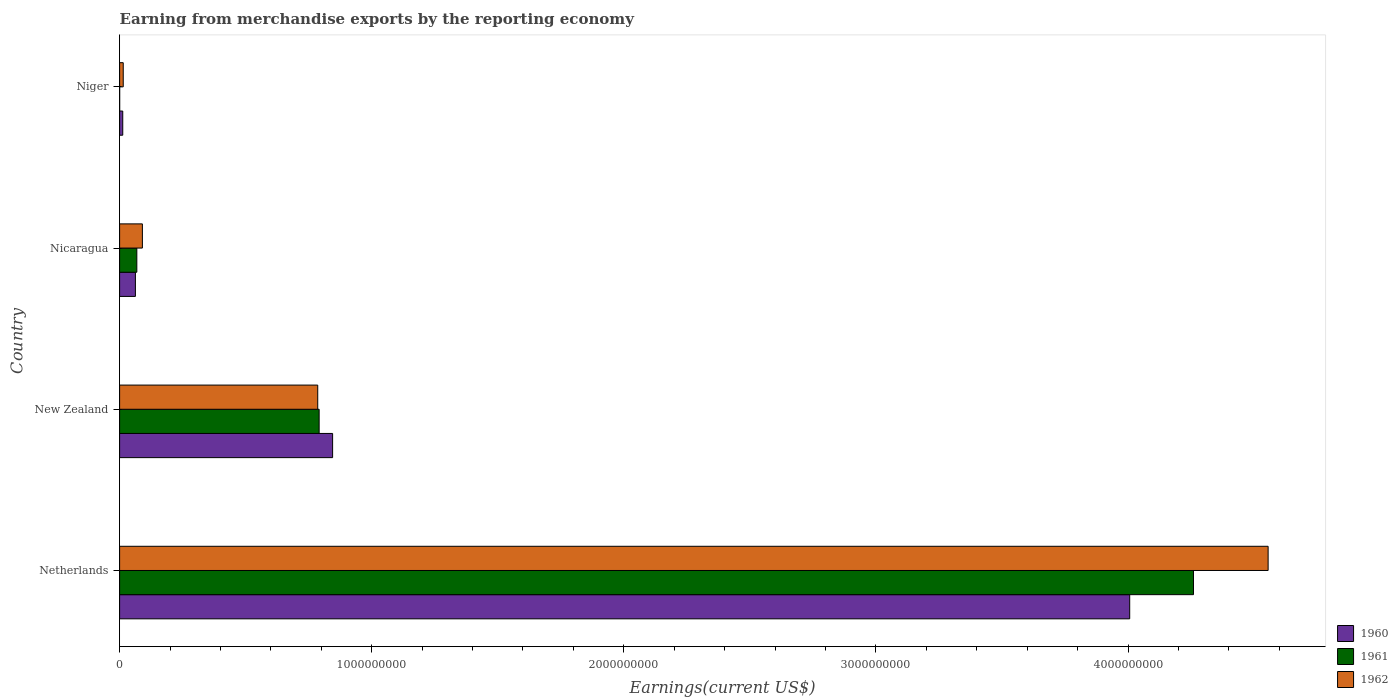How many groups of bars are there?
Provide a succinct answer. 4. What is the label of the 3rd group of bars from the top?
Provide a short and direct response. New Zealand. What is the amount earned from merchandise exports in 1961 in Nicaragua?
Your response must be concise. 6.83e+07. Across all countries, what is the maximum amount earned from merchandise exports in 1961?
Your answer should be compact. 4.26e+09. Across all countries, what is the minimum amount earned from merchandise exports in 1962?
Your answer should be very brief. 1.44e+07. In which country was the amount earned from merchandise exports in 1962 maximum?
Ensure brevity in your answer.  Netherlands. In which country was the amount earned from merchandise exports in 1961 minimum?
Offer a very short reply. Niger. What is the total amount earned from merchandise exports in 1961 in the graph?
Your response must be concise. 5.12e+09. What is the difference between the amount earned from merchandise exports in 1960 in Netherlands and that in Nicaragua?
Offer a very short reply. 3.94e+09. What is the difference between the amount earned from merchandise exports in 1962 in New Zealand and the amount earned from merchandise exports in 1960 in Niger?
Give a very brief answer. 7.73e+08. What is the average amount earned from merchandise exports in 1961 per country?
Give a very brief answer. 1.28e+09. What is the difference between the amount earned from merchandise exports in 1960 and amount earned from merchandise exports in 1961 in Nicaragua?
Your answer should be compact. -5.60e+06. What is the ratio of the amount earned from merchandise exports in 1962 in Netherlands to that in Niger?
Provide a succinct answer. 316.38. Is the amount earned from merchandise exports in 1962 in Netherlands less than that in Niger?
Keep it short and to the point. No. What is the difference between the highest and the second highest amount earned from merchandise exports in 1960?
Make the answer very short. 3.16e+09. What is the difference between the highest and the lowest amount earned from merchandise exports in 1962?
Provide a succinct answer. 4.54e+09. What does the 1st bar from the bottom in Nicaragua represents?
Make the answer very short. 1960. Is it the case that in every country, the sum of the amount earned from merchandise exports in 1962 and amount earned from merchandise exports in 1960 is greater than the amount earned from merchandise exports in 1961?
Offer a very short reply. Yes. How many bars are there?
Offer a terse response. 12. What is the difference between two consecutive major ticks on the X-axis?
Your response must be concise. 1.00e+09. Are the values on the major ticks of X-axis written in scientific E-notation?
Your answer should be compact. No. Does the graph contain any zero values?
Offer a terse response. No. Where does the legend appear in the graph?
Give a very brief answer. Bottom right. What is the title of the graph?
Provide a short and direct response. Earning from merchandise exports by the reporting economy. Does "2015" appear as one of the legend labels in the graph?
Keep it short and to the point. No. What is the label or title of the X-axis?
Provide a short and direct response. Earnings(current US$). What is the label or title of the Y-axis?
Your answer should be very brief. Country. What is the Earnings(current US$) of 1960 in Netherlands?
Keep it short and to the point. 4.01e+09. What is the Earnings(current US$) in 1961 in Netherlands?
Your answer should be very brief. 4.26e+09. What is the Earnings(current US$) of 1962 in Netherlands?
Your answer should be compact. 4.56e+09. What is the Earnings(current US$) in 1960 in New Zealand?
Provide a short and direct response. 8.45e+08. What is the Earnings(current US$) in 1961 in New Zealand?
Your answer should be very brief. 7.92e+08. What is the Earnings(current US$) of 1962 in New Zealand?
Your response must be concise. 7.86e+08. What is the Earnings(current US$) of 1960 in Nicaragua?
Provide a short and direct response. 6.27e+07. What is the Earnings(current US$) in 1961 in Nicaragua?
Provide a short and direct response. 6.83e+07. What is the Earnings(current US$) in 1962 in Nicaragua?
Provide a succinct answer. 9.04e+07. What is the Earnings(current US$) of 1960 in Niger?
Provide a short and direct response. 1.25e+07. What is the Earnings(current US$) of 1962 in Niger?
Your answer should be very brief. 1.44e+07. Across all countries, what is the maximum Earnings(current US$) of 1960?
Give a very brief answer. 4.01e+09. Across all countries, what is the maximum Earnings(current US$) of 1961?
Offer a very short reply. 4.26e+09. Across all countries, what is the maximum Earnings(current US$) of 1962?
Provide a succinct answer. 4.56e+09. Across all countries, what is the minimum Earnings(current US$) in 1960?
Your response must be concise. 1.25e+07. Across all countries, what is the minimum Earnings(current US$) in 1961?
Make the answer very short. 2.00e+05. Across all countries, what is the minimum Earnings(current US$) in 1962?
Ensure brevity in your answer.  1.44e+07. What is the total Earnings(current US$) in 1960 in the graph?
Make the answer very short. 4.93e+09. What is the total Earnings(current US$) of 1961 in the graph?
Your answer should be very brief. 5.12e+09. What is the total Earnings(current US$) in 1962 in the graph?
Give a very brief answer. 5.45e+09. What is the difference between the Earnings(current US$) in 1960 in Netherlands and that in New Zealand?
Make the answer very short. 3.16e+09. What is the difference between the Earnings(current US$) in 1961 in Netherlands and that in New Zealand?
Provide a short and direct response. 3.47e+09. What is the difference between the Earnings(current US$) of 1962 in Netherlands and that in New Zealand?
Offer a terse response. 3.77e+09. What is the difference between the Earnings(current US$) of 1960 in Netherlands and that in Nicaragua?
Offer a terse response. 3.94e+09. What is the difference between the Earnings(current US$) of 1961 in Netherlands and that in Nicaragua?
Provide a short and direct response. 4.19e+09. What is the difference between the Earnings(current US$) in 1962 in Netherlands and that in Nicaragua?
Your response must be concise. 4.47e+09. What is the difference between the Earnings(current US$) in 1960 in Netherlands and that in Niger?
Ensure brevity in your answer.  3.99e+09. What is the difference between the Earnings(current US$) of 1961 in Netherlands and that in Niger?
Your response must be concise. 4.26e+09. What is the difference between the Earnings(current US$) of 1962 in Netherlands and that in Niger?
Offer a terse response. 4.54e+09. What is the difference between the Earnings(current US$) in 1960 in New Zealand and that in Nicaragua?
Provide a short and direct response. 7.82e+08. What is the difference between the Earnings(current US$) of 1961 in New Zealand and that in Nicaragua?
Your answer should be very brief. 7.23e+08. What is the difference between the Earnings(current US$) in 1962 in New Zealand and that in Nicaragua?
Provide a short and direct response. 6.96e+08. What is the difference between the Earnings(current US$) of 1960 in New Zealand and that in Niger?
Offer a very short reply. 8.32e+08. What is the difference between the Earnings(current US$) in 1961 in New Zealand and that in Niger?
Offer a very short reply. 7.91e+08. What is the difference between the Earnings(current US$) in 1962 in New Zealand and that in Niger?
Your answer should be very brief. 7.72e+08. What is the difference between the Earnings(current US$) in 1960 in Nicaragua and that in Niger?
Offer a very short reply. 5.02e+07. What is the difference between the Earnings(current US$) of 1961 in Nicaragua and that in Niger?
Make the answer very short. 6.81e+07. What is the difference between the Earnings(current US$) of 1962 in Nicaragua and that in Niger?
Your response must be concise. 7.60e+07. What is the difference between the Earnings(current US$) of 1960 in Netherlands and the Earnings(current US$) of 1961 in New Zealand?
Your answer should be compact. 3.22e+09. What is the difference between the Earnings(current US$) in 1960 in Netherlands and the Earnings(current US$) in 1962 in New Zealand?
Ensure brevity in your answer.  3.22e+09. What is the difference between the Earnings(current US$) in 1961 in Netherlands and the Earnings(current US$) in 1962 in New Zealand?
Your response must be concise. 3.47e+09. What is the difference between the Earnings(current US$) of 1960 in Netherlands and the Earnings(current US$) of 1961 in Nicaragua?
Offer a terse response. 3.94e+09. What is the difference between the Earnings(current US$) in 1960 in Netherlands and the Earnings(current US$) in 1962 in Nicaragua?
Ensure brevity in your answer.  3.92e+09. What is the difference between the Earnings(current US$) in 1961 in Netherlands and the Earnings(current US$) in 1962 in Nicaragua?
Offer a very short reply. 4.17e+09. What is the difference between the Earnings(current US$) in 1960 in Netherlands and the Earnings(current US$) in 1961 in Niger?
Your answer should be very brief. 4.01e+09. What is the difference between the Earnings(current US$) in 1960 in Netherlands and the Earnings(current US$) in 1962 in Niger?
Ensure brevity in your answer.  3.99e+09. What is the difference between the Earnings(current US$) in 1961 in Netherlands and the Earnings(current US$) in 1962 in Niger?
Keep it short and to the point. 4.25e+09. What is the difference between the Earnings(current US$) of 1960 in New Zealand and the Earnings(current US$) of 1961 in Nicaragua?
Give a very brief answer. 7.77e+08. What is the difference between the Earnings(current US$) in 1960 in New Zealand and the Earnings(current US$) in 1962 in Nicaragua?
Give a very brief answer. 7.54e+08. What is the difference between the Earnings(current US$) in 1961 in New Zealand and the Earnings(current US$) in 1962 in Nicaragua?
Make the answer very short. 7.01e+08. What is the difference between the Earnings(current US$) of 1960 in New Zealand and the Earnings(current US$) of 1961 in Niger?
Keep it short and to the point. 8.45e+08. What is the difference between the Earnings(current US$) in 1960 in New Zealand and the Earnings(current US$) in 1962 in Niger?
Ensure brevity in your answer.  8.30e+08. What is the difference between the Earnings(current US$) in 1961 in New Zealand and the Earnings(current US$) in 1962 in Niger?
Ensure brevity in your answer.  7.77e+08. What is the difference between the Earnings(current US$) of 1960 in Nicaragua and the Earnings(current US$) of 1961 in Niger?
Offer a very short reply. 6.25e+07. What is the difference between the Earnings(current US$) of 1960 in Nicaragua and the Earnings(current US$) of 1962 in Niger?
Your answer should be very brief. 4.83e+07. What is the difference between the Earnings(current US$) in 1961 in Nicaragua and the Earnings(current US$) in 1962 in Niger?
Your answer should be very brief. 5.39e+07. What is the average Earnings(current US$) in 1960 per country?
Offer a very short reply. 1.23e+09. What is the average Earnings(current US$) in 1961 per country?
Your response must be concise. 1.28e+09. What is the average Earnings(current US$) in 1962 per country?
Provide a short and direct response. 1.36e+09. What is the difference between the Earnings(current US$) in 1960 and Earnings(current US$) in 1961 in Netherlands?
Give a very brief answer. -2.53e+08. What is the difference between the Earnings(current US$) of 1960 and Earnings(current US$) of 1962 in Netherlands?
Your response must be concise. -5.49e+08. What is the difference between the Earnings(current US$) in 1961 and Earnings(current US$) in 1962 in Netherlands?
Your response must be concise. -2.96e+08. What is the difference between the Earnings(current US$) of 1960 and Earnings(current US$) of 1961 in New Zealand?
Your answer should be compact. 5.34e+07. What is the difference between the Earnings(current US$) of 1960 and Earnings(current US$) of 1962 in New Zealand?
Give a very brief answer. 5.90e+07. What is the difference between the Earnings(current US$) of 1961 and Earnings(current US$) of 1962 in New Zealand?
Your answer should be very brief. 5.60e+06. What is the difference between the Earnings(current US$) in 1960 and Earnings(current US$) in 1961 in Nicaragua?
Your answer should be compact. -5.60e+06. What is the difference between the Earnings(current US$) of 1960 and Earnings(current US$) of 1962 in Nicaragua?
Your response must be concise. -2.77e+07. What is the difference between the Earnings(current US$) of 1961 and Earnings(current US$) of 1962 in Nicaragua?
Offer a very short reply. -2.21e+07. What is the difference between the Earnings(current US$) of 1960 and Earnings(current US$) of 1961 in Niger?
Keep it short and to the point. 1.23e+07. What is the difference between the Earnings(current US$) in 1960 and Earnings(current US$) in 1962 in Niger?
Provide a succinct answer. -1.90e+06. What is the difference between the Earnings(current US$) of 1961 and Earnings(current US$) of 1962 in Niger?
Your answer should be compact. -1.42e+07. What is the ratio of the Earnings(current US$) of 1960 in Netherlands to that in New Zealand?
Your answer should be compact. 4.74. What is the ratio of the Earnings(current US$) in 1961 in Netherlands to that in New Zealand?
Offer a very short reply. 5.38. What is the ratio of the Earnings(current US$) of 1962 in Netherlands to that in New Zealand?
Make the answer very short. 5.8. What is the ratio of the Earnings(current US$) in 1960 in Netherlands to that in Nicaragua?
Your answer should be very brief. 63.9. What is the ratio of the Earnings(current US$) in 1961 in Netherlands to that in Nicaragua?
Provide a short and direct response. 62.37. What is the ratio of the Earnings(current US$) in 1962 in Netherlands to that in Nicaragua?
Your answer should be compact. 50.4. What is the ratio of the Earnings(current US$) in 1960 in Netherlands to that in Niger?
Provide a succinct answer. 320.54. What is the ratio of the Earnings(current US$) of 1961 in Netherlands to that in Niger?
Your answer should be compact. 2.13e+04. What is the ratio of the Earnings(current US$) in 1962 in Netherlands to that in Niger?
Provide a short and direct response. 316.38. What is the ratio of the Earnings(current US$) of 1960 in New Zealand to that in Nicaragua?
Your answer should be very brief. 13.48. What is the ratio of the Earnings(current US$) in 1961 in New Zealand to that in Nicaragua?
Offer a very short reply. 11.59. What is the ratio of the Earnings(current US$) of 1962 in New Zealand to that in Nicaragua?
Keep it short and to the point. 8.69. What is the ratio of the Earnings(current US$) in 1960 in New Zealand to that in Niger?
Offer a terse response. 67.59. What is the ratio of the Earnings(current US$) of 1961 in New Zealand to that in Niger?
Make the answer very short. 3957.5. What is the ratio of the Earnings(current US$) of 1962 in New Zealand to that in Niger?
Your response must be concise. 54.58. What is the ratio of the Earnings(current US$) of 1960 in Nicaragua to that in Niger?
Keep it short and to the point. 5.02. What is the ratio of the Earnings(current US$) in 1961 in Nicaragua to that in Niger?
Give a very brief answer. 341.5. What is the ratio of the Earnings(current US$) in 1962 in Nicaragua to that in Niger?
Give a very brief answer. 6.28. What is the difference between the highest and the second highest Earnings(current US$) in 1960?
Make the answer very short. 3.16e+09. What is the difference between the highest and the second highest Earnings(current US$) of 1961?
Your response must be concise. 3.47e+09. What is the difference between the highest and the second highest Earnings(current US$) in 1962?
Your answer should be compact. 3.77e+09. What is the difference between the highest and the lowest Earnings(current US$) of 1960?
Your answer should be very brief. 3.99e+09. What is the difference between the highest and the lowest Earnings(current US$) of 1961?
Your response must be concise. 4.26e+09. What is the difference between the highest and the lowest Earnings(current US$) of 1962?
Your answer should be compact. 4.54e+09. 